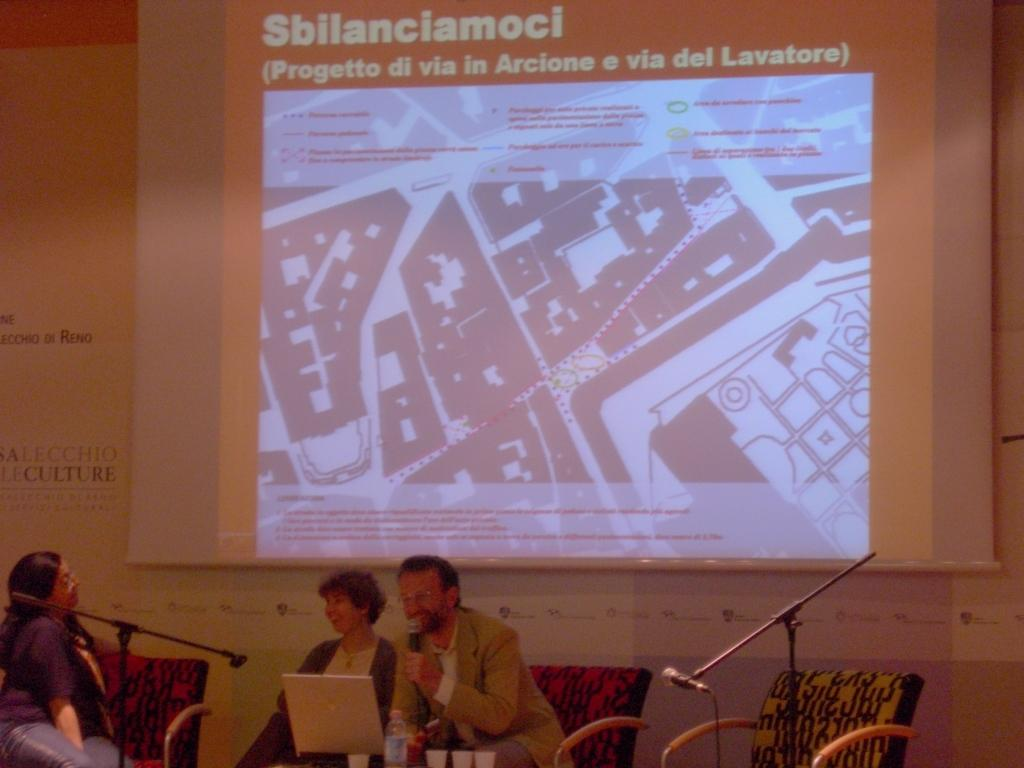How many people are present in the image? There are three people in the image. What is the man holding in the image? The man is holding a microphone. What is the man doing with the microphone? The man is speaking into the microphone. What can be seen on the background of the image? There is a projector screen in the image. Can you see any crackers being passed around in the image? There is no mention of crackers in the image, so it cannot be determined if any are being passed around. 